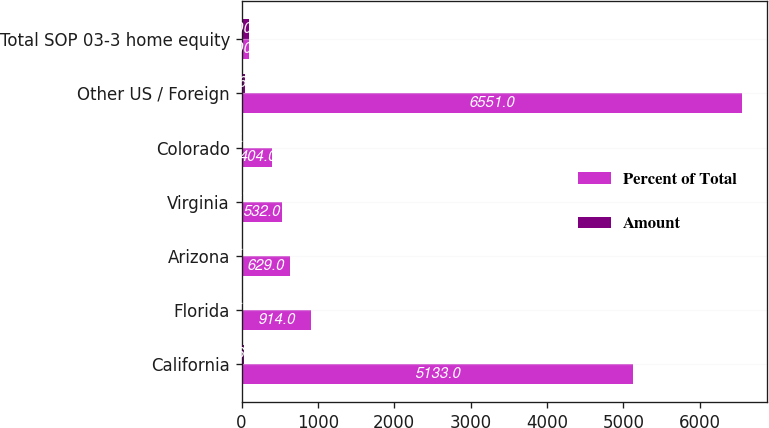<chart> <loc_0><loc_0><loc_500><loc_500><stacked_bar_chart><ecel><fcel>California<fcel>Florida<fcel>Arizona<fcel>Virginia<fcel>Colorado<fcel>Other US / Foreign<fcel>Total SOP 03-3 home equity<nl><fcel>Percent of Total<fcel>5133<fcel>914<fcel>629<fcel>532<fcel>404<fcel>6551<fcel>100<nl><fcel>Amount<fcel>36.2<fcel>6.5<fcel>4.4<fcel>3.8<fcel>2.9<fcel>46.2<fcel>100<nl></chart> 